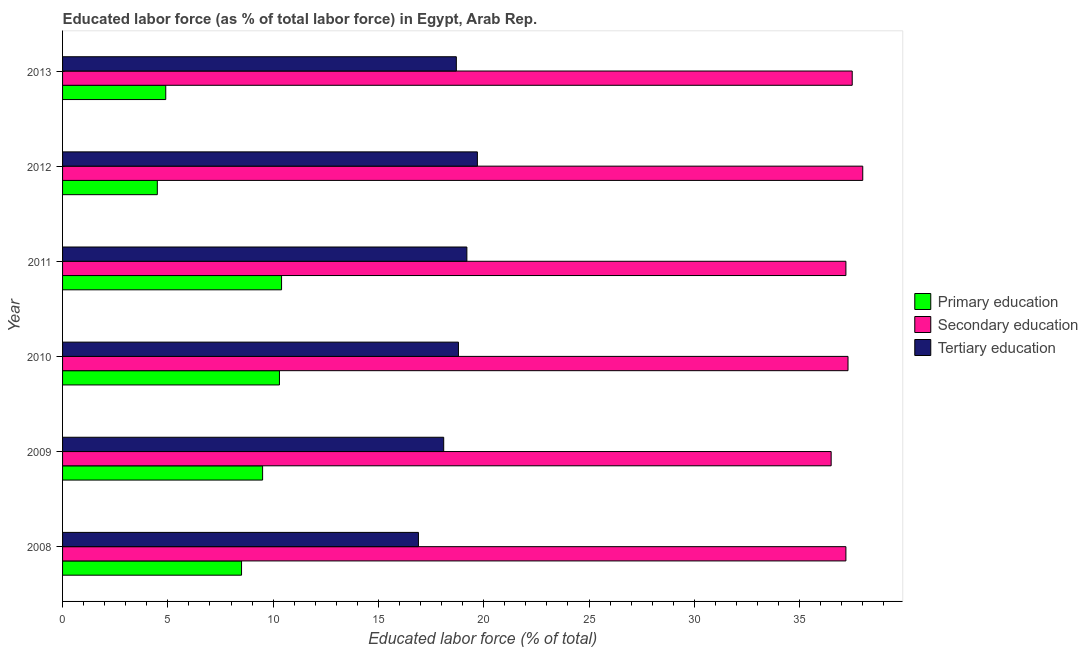How many groups of bars are there?
Make the answer very short. 6. Are the number of bars per tick equal to the number of legend labels?
Your response must be concise. Yes. How many bars are there on the 1st tick from the top?
Make the answer very short. 3. What is the percentage of labor force who received secondary education in 2009?
Keep it short and to the point. 36.5. Across all years, what is the maximum percentage of labor force who received tertiary education?
Give a very brief answer. 19.7. Across all years, what is the minimum percentage of labor force who received secondary education?
Make the answer very short. 36.5. In which year was the percentage of labor force who received primary education maximum?
Your response must be concise. 2011. What is the total percentage of labor force who received primary education in the graph?
Offer a very short reply. 48.1. What is the difference between the percentage of labor force who received tertiary education in 2008 and that in 2012?
Offer a terse response. -2.8. What is the difference between the percentage of labor force who received primary education in 2012 and the percentage of labor force who received secondary education in 2009?
Provide a short and direct response. -32. What is the average percentage of labor force who received secondary education per year?
Offer a very short reply. 37.28. What is the ratio of the percentage of labor force who received tertiary education in 2010 to that in 2012?
Make the answer very short. 0.95. What does the 2nd bar from the top in 2011 represents?
Provide a short and direct response. Secondary education. What does the 3rd bar from the bottom in 2008 represents?
Offer a terse response. Tertiary education. Are all the bars in the graph horizontal?
Your answer should be very brief. Yes. How many years are there in the graph?
Your response must be concise. 6. Does the graph contain grids?
Ensure brevity in your answer.  No. Where does the legend appear in the graph?
Your answer should be very brief. Center right. What is the title of the graph?
Your answer should be compact. Educated labor force (as % of total labor force) in Egypt, Arab Rep. What is the label or title of the X-axis?
Offer a very short reply. Educated labor force (% of total). What is the label or title of the Y-axis?
Offer a very short reply. Year. What is the Educated labor force (% of total) of Primary education in 2008?
Ensure brevity in your answer.  8.5. What is the Educated labor force (% of total) of Secondary education in 2008?
Ensure brevity in your answer.  37.2. What is the Educated labor force (% of total) in Tertiary education in 2008?
Offer a terse response. 16.9. What is the Educated labor force (% of total) of Primary education in 2009?
Your answer should be compact. 9.5. What is the Educated labor force (% of total) of Secondary education in 2009?
Give a very brief answer. 36.5. What is the Educated labor force (% of total) in Tertiary education in 2009?
Provide a short and direct response. 18.1. What is the Educated labor force (% of total) of Primary education in 2010?
Your answer should be very brief. 10.3. What is the Educated labor force (% of total) in Secondary education in 2010?
Your answer should be very brief. 37.3. What is the Educated labor force (% of total) in Tertiary education in 2010?
Provide a short and direct response. 18.8. What is the Educated labor force (% of total) of Primary education in 2011?
Give a very brief answer. 10.4. What is the Educated labor force (% of total) in Secondary education in 2011?
Provide a short and direct response. 37.2. What is the Educated labor force (% of total) of Tertiary education in 2011?
Your response must be concise. 19.2. What is the Educated labor force (% of total) in Primary education in 2012?
Offer a terse response. 4.5. What is the Educated labor force (% of total) of Tertiary education in 2012?
Provide a short and direct response. 19.7. What is the Educated labor force (% of total) in Primary education in 2013?
Make the answer very short. 4.9. What is the Educated labor force (% of total) in Secondary education in 2013?
Your answer should be very brief. 37.5. What is the Educated labor force (% of total) in Tertiary education in 2013?
Give a very brief answer. 18.7. Across all years, what is the maximum Educated labor force (% of total) in Primary education?
Ensure brevity in your answer.  10.4. Across all years, what is the maximum Educated labor force (% of total) in Secondary education?
Make the answer very short. 38. Across all years, what is the maximum Educated labor force (% of total) of Tertiary education?
Offer a very short reply. 19.7. Across all years, what is the minimum Educated labor force (% of total) in Primary education?
Keep it short and to the point. 4.5. Across all years, what is the minimum Educated labor force (% of total) of Secondary education?
Ensure brevity in your answer.  36.5. Across all years, what is the minimum Educated labor force (% of total) in Tertiary education?
Give a very brief answer. 16.9. What is the total Educated labor force (% of total) of Primary education in the graph?
Your response must be concise. 48.1. What is the total Educated labor force (% of total) in Secondary education in the graph?
Provide a short and direct response. 223.7. What is the total Educated labor force (% of total) of Tertiary education in the graph?
Make the answer very short. 111.4. What is the difference between the Educated labor force (% of total) in Secondary education in 2008 and that in 2010?
Offer a terse response. -0.1. What is the difference between the Educated labor force (% of total) in Tertiary education in 2008 and that in 2011?
Your response must be concise. -2.3. What is the difference between the Educated labor force (% of total) in Primary education in 2008 and that in 2012?
Offer a very short reply. 4. What is the difference between the Educated labor force (% of total) in Secondary education in 2008 and that in 2012?
Keep it short and to the point. -0.8. What is the difference between the Educated labor force (% of total) of Tertiary education in 2008 and that in 2012?
Your answer should be compact. -2.8. What is the difference between the Educated labor force (% of total) of Primary education in 2008 and that in 2013?
Give a very brief answer. 3.6. What is the difference between the Educated labor force (% of total) in Tertiary education in 2008 and that in 2013?
Provide a succinct answer. -1.8. What is the difference between the Educated labor force (% of total) of Secondary education in 2009 and that in 2010?
Give a very brief answer. -0.8. What is the difference between the Educated labor force (% of total) in Tertiary education in 2009 and that in 2010?
Your response must be concise. -0.7. What is the difference between the Educated labor force (% of total) of Tertiary education in 2009 and that in 2011?
Offer a terse response. -1.1. What is the difference between the Educated labor force (% of total) in Primary education in 2009 and that in 2012?
Ensure brevity in your answer.  5. What is the difference between the Educated labor force (% of total) of Secondary education in 2009 and that in 2012?
Keep it short and to the point. -1.5. What is the difference between the Educated labor force (% of total) of Tertiary education in 2009 and that in 2012?
Your answer should be compact. -1.6. What is the difference between the Educated labor force (% of total) in Primary education in 2009 and that in 2013?
Your answer should be compact. 4.6. What is the difference between the Educated labor force (% of total) in Secondary education in 2009 and that in 2013?
Your answer should be very brief. -1. What is the difference between the Educated labor force (% of total) in Primary education in 2010 and that in 2011?
Your answer should be very brief. -0.1. What is the difference between the Educated labor force (% of total) in Primary education in 2010 and that in 2012?
Offer a terse response. 5.8. What is the difference between the Educated labor force (% of total) in Tertiary education in 2010 and that in 2013?
Your response must be concise. 0.1. What is the difference between the Educated labor force (% of total) of Primary education in 2011 and that in 2012?
Provide a short and direct response. 5.9. What is the difference between the Educated labor force (% of total) in Secondary education in 2011 and that in 2012?
Provide a short and direct response. -0.8. What is the difference between the Educated labor force (% of total) in Tertiary education in 2011 and that in 2012?
Offer a very short reply. -0.5. What is the difference between the Educated labor force (% of total) in Secondary education in 2011 and that in 2013?
Make the answer very short. -0.3. What is the difference between the Educated labor force (% of total) in Tertiary education in 2012 and that in 2013?
Provide a succinct answer. 1. What is the difference between the Educated labor force (% of total) in Primary education in 2008 and the Educated labor force (% of total) in Tertiary education in 2009?
Your answer should be compact. -9.6. What is the difference between the Educated labor force (% of total) of Secondary education in 2008 and the Educated labor force (% of total) of Tertiary education in 2009?
Keep it short and to the point. 19.1. What is the difference between the Educated labor force (% of total) in Primary education in 2008 and the Educated labor force (% of total) in Secondary education in 2010?
Your response must be concise. -28.8. What is the difference between the Educated labor force (% of total) of Primary education in 2008 and the Educated labor force (% of total) of Tertiary education in 2010?
Provide a short and direct response. -10.3. What is the difference between the Educated labor force (% of total) in Primary education in 2008 and the Educated labor force (% of total) in Secondary education in 2011?
Give a very brief answer. -28.7. What is the difference between the Educated labor force (% of total) in Primary education in 2008 and the Educated labor force (% of total) in Secondary education in 2012?
Provide a short and direct response. -29.5. What is the difference between the Educated labor force (% of total) of Primary education in 2008 and the Educated labor force (% of total) of Tertiary education in 2012?
Make the answer very short. -11.2. What is the difference between the Educated labor force (% of total) of Primary education in 2009 and the Educated labor force (% of total) of Secondary education in 2010?
Your answer should be very brief. -27.8. What is the difference between the Educated labor force (% of total) in Primary education in 2009 and the Educated labor force (% of total) in Tertiary education in 2010?
Your answer should be compact. -9.3. What is the difference between the Educated labor force (% of total) of Secondary education in 2009 and the Educated labor force (% of total) of Tertiary education in 2010?
Your answer should be very brief. 17.7. What is the difference between the Educated labor force (% of total) in Primary education in 2009 and the Educated labor force (% of total) in Secondary education in 2011?
Provide a short and direct response. -27.7. What is the difference between the Educated labor force (% of total) of Primary education in 2009 and the Educated labor force (% of total) of Tertiary education in 2011?
Your response must be concise. -9.7. What is the difference between the Educated labor force (% of total) in Primary education in 2009 and the Educated labor force (% of total) in Secondary education in 2012?
Your answer should be compact. -28.5. What is the difference between the Educated labor force (% of total) in Secondary education in 2009 and the Educated labor force (% of total) in Tertiary education in 2013?
Keep it short and to the point. 17.8. What is the difference between the Educated labor force (% of total) of Primary education in 2010 and the Educated labor force (% of total) of Secondary education in 2011?
Your answer should be very brief. -26.9. What is the difference between the Educated labor force (% of total) of Primary education in 2010 and the Educated labor force (% of total) of Tertiary education in 2011?
Make the answer very short. -8.9. What is the difference between the Educated labor force (% of total) in Primary education in 2010 and the Educated labor force (% of total) in Secondary education in 2012?
Provide a short and direct response. -27.7. What is the difference between the Educated labor force (% of total) of Primary education in 2010 and the Educated labor force (% of total) of Tertiary education in 2012?
Ensure brevity in your answer.  -9.4. What is the difference between the Educated labor force (% of total) in Secondary education in 2010 and the Educated labor force (% of total) in Tertiary education in 2012?
Your response must be concise. 17.6. What is the difference between the Educated labor force (% of total) in Primary education in 2010 and the Educated labor force (% of total) in Secondary education in 2013?
Provide a short and direct response. -27.2. What is the difference between the Educated labor force (% of total) of Secondary education in 2010 and the Educated labor force (% of total) of Tertiary education in 2013?
Your response must be concise. 18.6. What is the difference between the Educated labor force (% of total) in Primary education in 2011 and the Educated labor force (% of total) in Secondary education in 2012?
Make the answer very short. -27.6. What is the difference between the Educated labor force (% of total) in Primary education in 2011 and the Educated labor force (% of total) in Tertiary education in 2012?
Your answer should be very brief. -9.3. What is the difference between the Educated labor force (% of total) in Primary education in 2011 and the Educated labor force (% of total) in Secondary education in 2013?
Offer a very short reply. -27.1. What is the difference between the Educated labor force (% of total) in Primary education in 2011 and the Educated labor force (% of total) in Tertiary education in 2013?
Your answer should be compact. -8.3. What is the difference between the Educated labor force (% of total) of Primary education in 2012 and the Educated labor force (% of total) of Secondary education in 2013?
Keep it short and to the point. -33. What is the difference between the Educated labor force (% of total) of Primary education in 2012 and the Educated labor force (% of total) of Tertiary education in 2013?
Provide a succinct answer. -14.2. What is the difference between the Educated labor force (% of total) of Secondary education in 2012 and the Educated labor force (% of total) of Tertiary education in 2013?
Provide a short and direct response. 19.3. What is the average Educated labor force (% of total) of Primary education per year?
Provide a succinct answer. 8.02. What is the average Educated labor force (% of total) in Secondary education per year?
Keep it short and to the point. 37.28. What is the average Educated labor force (% of total) in Tertiary education per year?
Offer a very short reply. 18.57. In the year 2008, what is the difference between the Educated labor force (% of total) of Primary education and Educated labor force (% of total) of Secondary education?
Your answer should be very brief. -28.7. In the year 2008, what is the difference between the Educated labor force (% of total) in Primary education and Educated labor force (% of total) in Tertiary education?
Your answer should be very brief. -8.4. In the year 2008, what is the difference between the Educated labor force (% of total) of Secondary education and Educated labor force (% of total) of Tertiary education?
Your response must be concise. 20.3. In the year 2009, what is the difference between the Educated labor force (% of total) of Primary education and Educated labor force (% of total) of Secondary education?
Give a very brief answer. -27. In the year 2009, what is the difference between the Educated labor force (% of total) in Primary education and Educated labor force (% of total) in Tertiary education?
Your response must be concise. -8.6. In the year 2009, what is the difference between the Educated labor force (% of total) of Secondary education and Educated labor force (% of total) of Tertiary education?
Make the answer very short. 18.4. In the year 2010, what is the difference between the Educated labor force (% of total) in Primary education and Educated labor force (% of total) in Secondary education?
Your answer should be very brief. -27. In the year 2010, what is the difference between the Educated labor force (% of total) in Primary education and Educated labor force (% of total) in Tertiary education?
Give a very brief answer. -8.5. In the year 2010, what is the difference between the Educated labor force (% of total) of Secondary education and Educated labor force (% of total) of Tertiary education?
Provide a short and direct response. 18.5. In the year 2011, what is the difference between the Educated labor force (% of total) in Primary education and Educated labor force (% of total) in Secondary education?
Give a very brief answer. -26.8. In the year 2012, what is the difference between the Educated labor force (% of total) of Primary education and Educated labor force (% of total) of Secondary education?
Provide a succinct answer. -33.5. In the year 2012, what is the difference between the Educated labor force (% of total) in Primary education and Educated labor force (% of total) in Tertiary education?
Your answer should be compact. -15.2. In the year 2013, what is the difference between the Educated labor force (% of total) in Primary education and Educated labor force (% of total) in Secondary education?
Provide a short and direct response. -32.6. In the year 2013, what is the difference between the Educated labor force (% of total) of Primary education and Educated labor force (% of total) of Tertiary education?
Keep it short and to the point. -13.8. In the year 2013, what is the difference between the Educated labor force (% of total) in Secondary education and Educated labor force (% of total) in Tertiary education?
Keep it short and to the point. 18.8. What is the ratio of the Educated labor force (% of total) in Primary education in 2008 to that in 2009?
Make the answer very short. 0.89. What is the ratio of the Educated labor force (% of total) in Secondary education in 2008 to that in 2009?
Provide a succinct answer. 1.02. What is the ratio of the Educated labor force (% of total) of Tertiary education in 2008 to that in 2009?
Give a very brief answer. 0.93. What is the ratio of the Educated labor force (% of total) of Primary education in 2008 to that in 2010?
Keep it short and to the point. 0.83. What is the ratio of the Educated labor force (% of total) of Secondary education in 2008 to that in 2010?
Your response must be concise. 1. What is the ratio of the Educated labor force (% of total) in Tertiary education in 2008 to that in 2010?
Offer a terse response. 0.9. What is the ratio of the Educated labor force (% of total) in Primary education in 2008 to that in 2011?
Your response must be concise. 0.82. What is the ratio of the Educated labor force (% of total) in Secondary education in 2008 to that in 2011?
Your response must be concise. 1. What is the ratio of the Educated labor force (% of total) of Tertiary education in 2008 to that in 2011?
Give a very brief answer. 0.88. What is the ratio of the Educated labor force (% of total) of Primary education in 2008 to that in 2012?
Provide a short and direct response. 1.89. What is the ratio of the Educated labor force (% of total) in Secondary education in 2008 to that in 2012?
Your answer should be very brief. 0.98. What is the ratio of the Educated labor force (% of total) in Tertiary education in 2008 to that in 2012?
Provide a succinct answer. 0.86. What is the ratio of the Educated labor force (% of total) in Primary education in 2008 to that in 2013?
Provide a short and direct response. 1.73. What is the ratio of the Educated labor force (% of total) in Secondary education in 2008 to that in 2013?
Provide a short and direct response. 0.99. What is the ratio of the Educated labor force (% of total) in Tertiary education in 2008 to that in 2013?
Offer a very short reply. 0.9. What is the ratio of the Educated labor force (% of total) of Primary education in 2009 to that in 2010?
Your response must be concise. 0.92. What is the ratio of the Educated labor force (% of total) in Secondary education in 2009 to that in 2010?
Your answer should be compact. 0.98. What is the ratio of the Educated labor force (% of total) of Tertiary education in 2009 to that in 2010?
Offer a very short reply. 0.96. What is the ratio of the Educated labor force (% of total) of Primary education in 2009 to that in 2011?
Give a very brief answer. 0.91. What is the ratio of the Educated labor force (% of total) in Secondary education in 2009 to that in 2011?
Your answer should be compact. 0.98. What is the ratio of the Educated labor force (% of total) in Tertiary education in 2009 to that in 2011?
Provide a succinct answer. 0.94. What is the ratio of the Educated labor force (% of total) of Primary education in 2009 to that in 2012?
Your answer should be very brief. 2.11. What is the ratio of the Educated labor force (% of total) in Secondary education in 2009 to that in 2012?
Provide a short and direct response. 0.96. What is the ratio of the Educated labor force (% of total) of Tertiary education in 2009 to that in 2012?
Your answer should be compact. 0.92. What is the ratio of the Educated labor force (% of total) of Primary education in 2009 to that in 2013?
Offer a very short reply. 1.94. What is the ratio of the Educated labor force (% of total) in Secondary education in 2009 to that in 2013?
Offer a very short reply. 0.97. What is the ratio of the Educated labor force (% of total) of Tertiary education in 2009 to that in 2013?
Your response must be concise. 0.97. What is the ratio of the Educated labor force (% of total) of Primary education in 2010 to that in 2011?
Your answer should be very brief. 0.99. What is the ratio of the Educated labor force (% of total) of Secondary education in 2010 to that in 2011?
Provide a succinct answer. 1. What is the ratio of the Educated labor force (% of total) in Tertiary education in 2010 to that in 2011?
Your answer should be compact. 0.98. What is the ratio of the Educated labor force (% of total) of Primary education in 2010 to that in 2012?
Provide a succinct answer. 2.29. What is the ratio of the Educated labor force (% of total) of Secondary education in 2010 to that in 2012?
Your answer should be very brief. 0.98. What is the ratio of the Educated labor force (% of total) in Tertiary education in 2010 to that in 2012?
Provide a short and direct response. 0.95. What is the ratio of the Educated labor force (% of total) of Primary education in 2010 to that in 2013?
Provide a succinct answer. 2.1. What is the ratio of the Educated labor force (% of total) of Secondary education in 2010 to that in 2013?
Provide a succinct answer. 0.99. What is the ratio of the Educated labor force (% of total) in Primary education in 2011 to that in 2012?
Provide a succinct answer. 2.31. What is the ratio of the Educated labor force (% of total) in Secondary education in 2011 to that in 2012?
Your response must be concise. 0.98. What is the ratio of the Educated labor force (% of total) of Tertiary education in 2011 to that in 2012?
Ensure brevity in your answer.  0.97. What is the ratio of the Educated labor force (% of total) of Primary education in 2011 to that in 2013?
Ensure brevity in your answer.  2.12. What is the ratio of the Educated labor force (% of total) of Tertiary education in 2011 to that in 2013?
Make the answer very short. 1.03. What is the ratio of the Educated labor force (% of total) of Primary education in 2012 to that in 2013?
Ensure brevity in your answer.  0.92. What is the ratio of the Educated labor force (% of total) in Secondary education in 2012 to that in 2013?
Your response must be concise. 1.01. What is the ratio of the Educated labor force (% of total) of Tertiary education in 2012 to that in 2013?
Your response must be concise. 1.05. What is the difference between the highest and the second highest Educated labor force (% of total) in Secondary education?
Provide a short and direct response. 0.5. What is the difference between the highest and the lowest Educated labor force (% of total) in Primary education?
Your response must be concise. 5.9. 